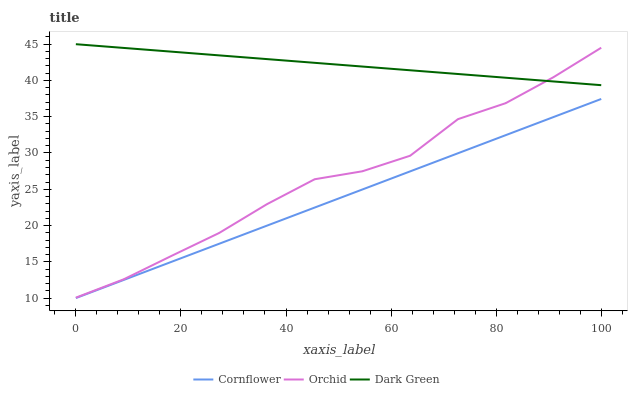Does Cornflower have the minimum area under the curve?
Answer yes or no. Yes. Does Dark Green have the maximum area under the curve?
Answer yes or no. Yes. Does Orchid have the minimum area under the curve?
Answer yes or no. No. Does Orchid have the maximum area under the curve?
Answer yes or no. No. Is Dark Green the smoothest?
Answer yes or no. Yes. Is Orchid the roughest?
Answer yes or no. Yes. Is Orchid the smoothest?
Answer yes or no. No. Is Dark Green the roughest?
Answer yes or no. No. Does Cornflower have the lowest value?
Answer yes or no. Yes. Does Orchid have the lowest value?
Answer yes or no. No. Does Dark Green have the highest value?
Answer yes or no. Yes. Does Orchid have the highest value?
Answer yes or no. No. Is Cornflower less than Orchid?
Answer yes or no. Yes. Is Orchid greater than Cornflower?
Answer yes or no. Yes. Does Dark Green intersect Orchid?
Answer yes or no. Yes. Is Dark Green less than Orchid?
Answer yes or no. No. Is Dark Green greater than Orchid?
Answer yes or no. No. Does Cornflower intersect Orchid?
Answer yes or no. No. 